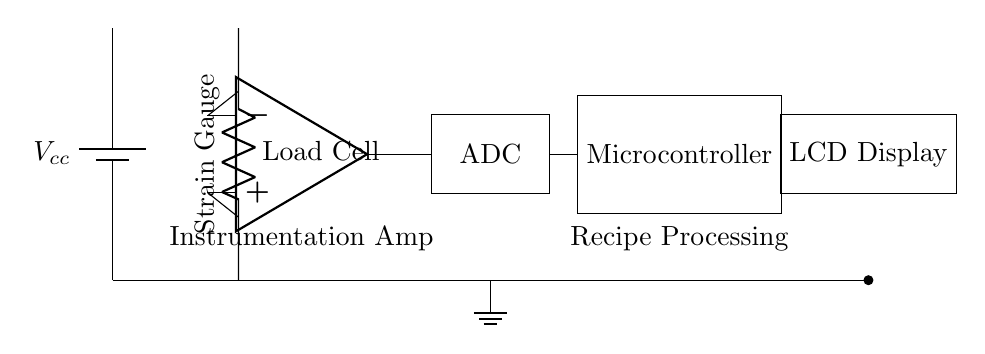What type of sensor is used in the circuit? The load cell depicted in the circuit is a type of sensor that measures weight or force. It typically uses a strain gauge to detect changes in resistance caused by deformation due to weight.
Answer: Load cell What is the role of the instrumentation amplifier? The instrumentation amplifier amplifies the small voltage signal from the load cell, which is crucial for accurate measurement because load cell output is typically very low. The op amp configuration allows for high gain and low noise.
Answer: Amplification What component converts the analog signal to digital? The Analog-to-Digital Converter (ADC) is responsible for converting the continuous analog signal from the instrumentation amplifier into a digital signal that can be processed by the microcontroller.
Answer: ADC How many components provide power in the circuit? The circuit contains one power supply component, represented by the battery, that provides the necessary voltage for the entire circuit operation.
Answer: One What is displayed on the LCD? The LCD display shows the measured weight or mass of the ingredients, providing real-time feedback as the user adds pet food ingredients for accurate measurement.
Answer: Measured weight What is the purpose of the microcontroller in this circuit? The microcontroller processes the digital signal from the ADC, interprets the data, and controls the display to provide a user-friendly interface for the pet owner. It could also include additional functionalities like storing recipes.
Answer: Recipe Processing What type of circuit does this diagram represent? This circuit diagram represents a control circuit designed specifically for precise measurement, focusing on the accuracy of weighing ingredients for homemade pet food recipes.
Answer: Control circuit 